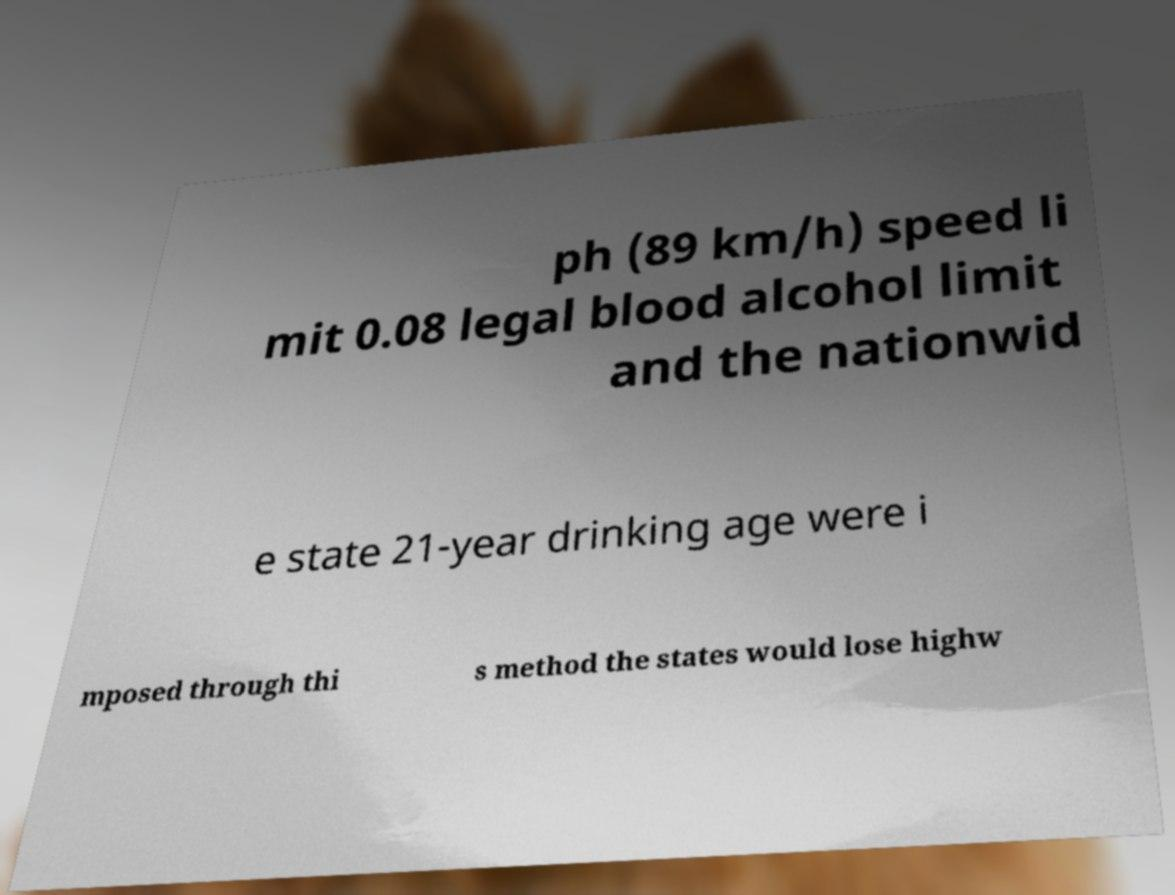Please read and relay the text visible in this image. What does it say? ph (89 km/h) speed li mit 0.08 legal blood alcohol limit and the nationwid e state 21-year drinking age were i mposed through thi s method the states would lose highw 